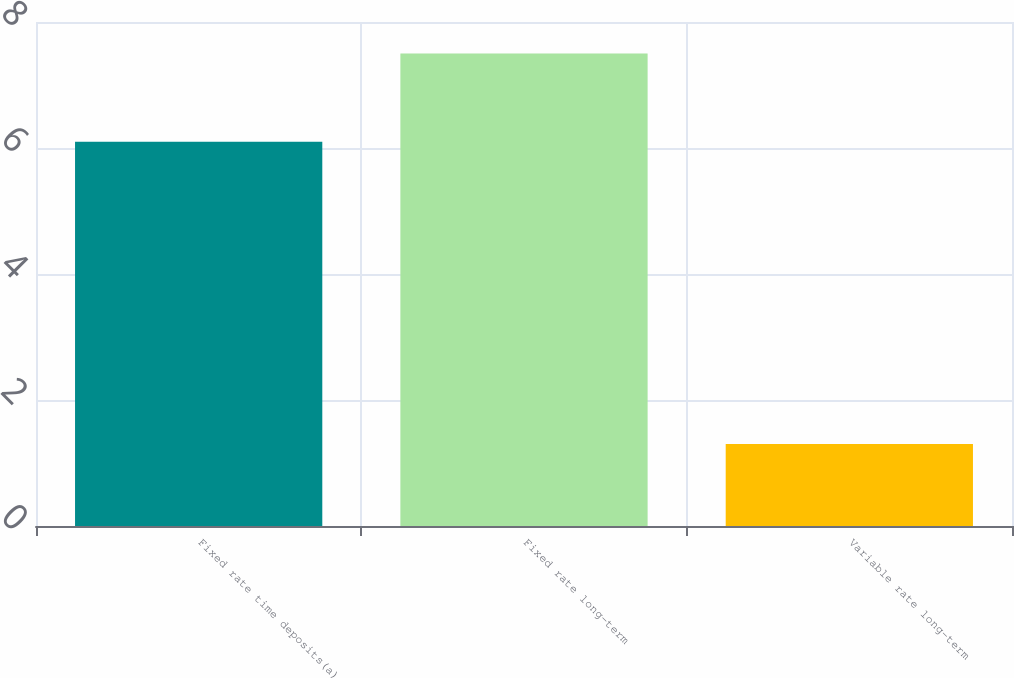<chart> <loc_0><loc_0><loc_500><loc_500><bar_chart><fcel>Fixed rate time deposits(a)<fcel>Fixed rate long-term<fcel>Variable rate long-term<nl><fcel>6.1<fcel>7.5<fcel>1.3<nl></chart> 